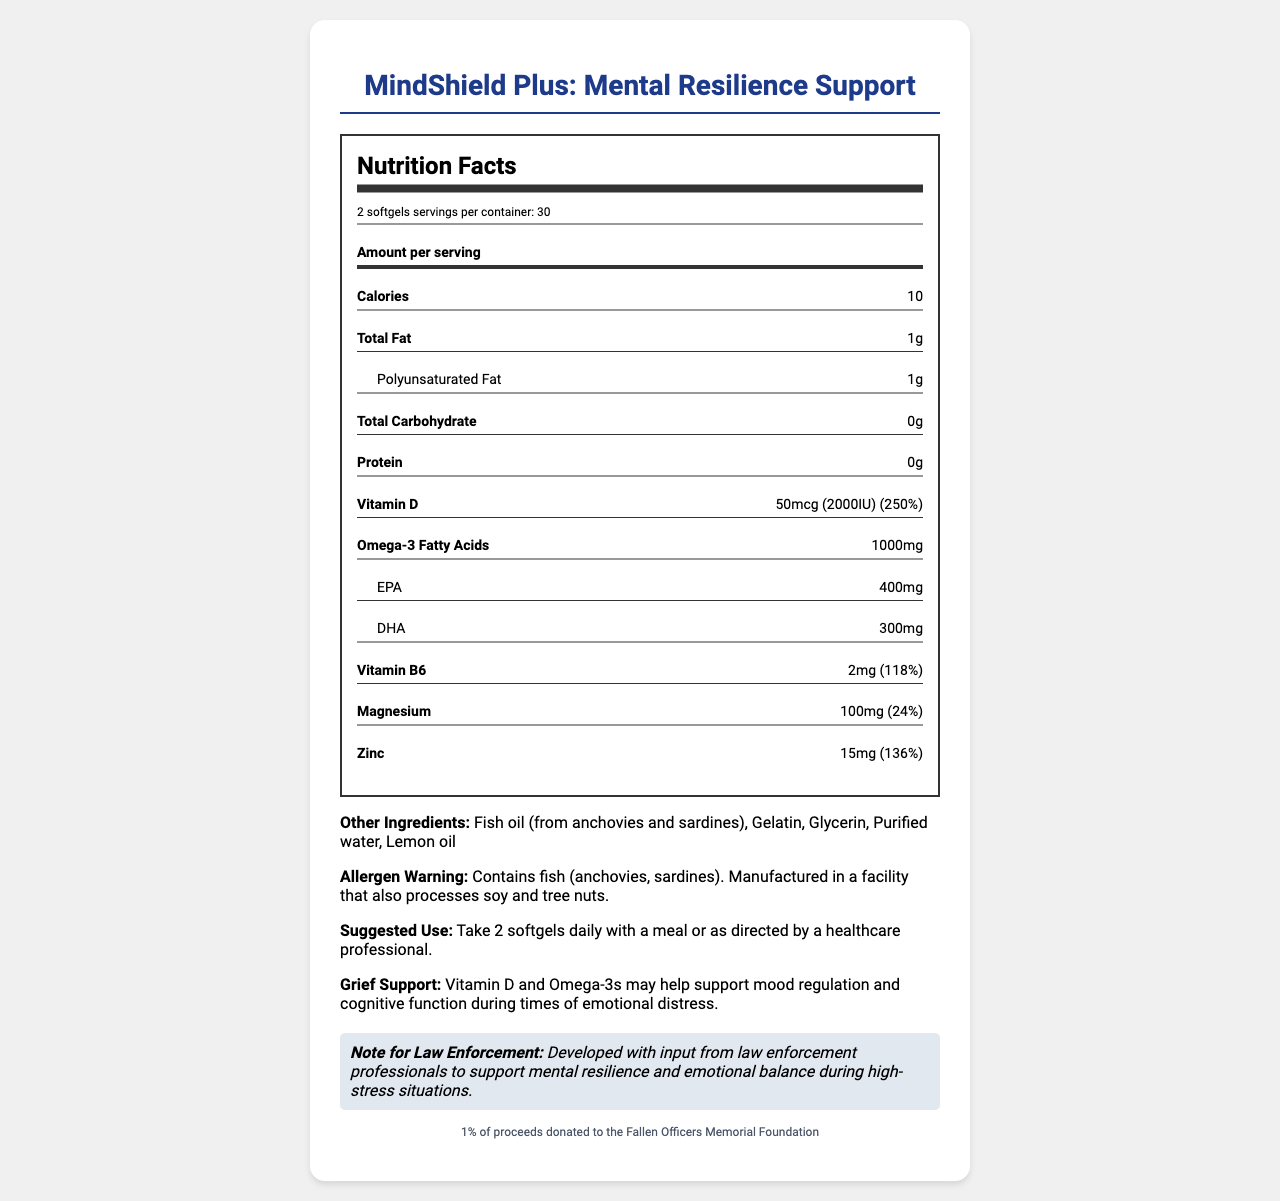what is the serving size? The serving size is listed as "2 softgels" in the serving information on the label.
Answer: 2 softgels how many calories are in a serving? The calories per serving are specified as 10 calories.
Answer: 10 calories what percentage of the daily value of vitamin D does one serving provide? The label indicates that one serving provides 50mcg (2000IU) of vitamin D, which is 250% of the daily value.
Answer: 250% list three other ingredients in the supplement. The other ingredients listed include Fish oil (from anchovies and sardines), Gelatin, Glycerin.
Answer: Fish oil, Gelatin, Glycerin how should this supplement be taken? The suggested use instructions specify taking 2 softgels daily with a meal or as directed by a healthcare professional.
Answer: Take 2 softgels daily with a meal or as directed by a healthcare professional. what is the primary source of omega-3 fatty acids in this supplement? The primary source of omega-3 fatty acids is fish oil, which comes from anchovies and sardines, as listed in the ingredients.
Answer: Fish oil (from anchovies and sardines) what is the total amount of omega-3 fatty acids per serving? The total amount of omega-3 fatty acids per serving is specified as 1000mg.
Answer: 1000mg does this product contain any allergens? The allergen warning states that the product contains fish (anchovies, sardines).
Answer: Yes, it contains fish (anchovies, sardines) what percentage of the daily value of zinc is provided per serving? The label indicates that one serving provides 15mg of zinc, which is 136% of the daily value.
Answer: 136% (A) What is the amount of EPA in this supplement? 
(B) How about DHA? 
1. EPA: 400mg, DHA: 300mg 
2. EPA: 300mg, DHA: 400mg 
3. EPA: 500mg, DHA: 350mg The supplement details list EPA as 400mg and DHA as 300mg per serving.
Answer: 1. EPA: 400mg, DHA: 300mg (A) What is the daily value percentage of vitamin B6 per serving? 
(B) And magnesium? 
I. 200% and 36% 
II. 118% and 24% 
III. 150% and 30% The label specifies 118% of the daily value for vitamin B6 and 24% for magnesium.
Answer: II. 118% and 24% is this supplement designed for police officers? The police officer note indicates it was developed with input from law enforcement professionals to support mental resilience and emotional balance during high-stress situations.
Answer: Yes summarize the document The summary describes the key elements of the document, detailing the product's purpose, ingredients, nutritional values, suggested use, and its special design for law enforcement professionals and their families.
Answer: The document provides the nutrition facts and details for a supplement named "MindShield Plus: Mental Resilience Support," which includes vitamins and omega-3 fatty acids aimed at supporting mental health, particularly for law enforcement professionals. The label lists serving size, calorie content, and amounts of key ingredients, as well as ingredients and allergen information. The supplement claims to support mood regulation and donates 1% of proceeds to the Fallen Officers Memorial Foundation. did the product receive FDA approval? The document does not provide any information about FDA approval, so this cannot be determined from the visual information provided.
Answer: Cannot be determined 